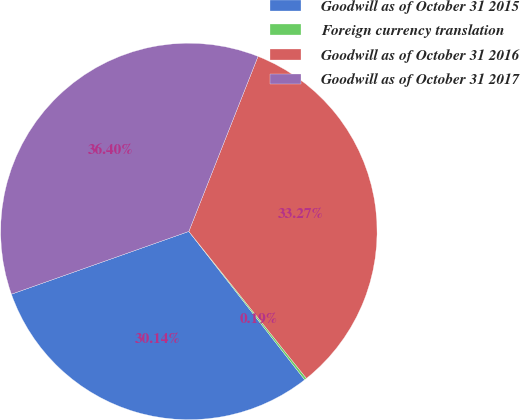Convert chart. <chart><loc_0><loc_0><loc_500><loc_500><pie_chart><fcel>Goodwill as of October 31 2015<fcel>Foreign currency translation<fcel>Goodwill as of October 31 2016<fcel>Goodwill as of October 31 2017<nl><fcel>30.14%<fcel>0.19%<fcel>33.27%<fcel>36.4%<nl></chart> 